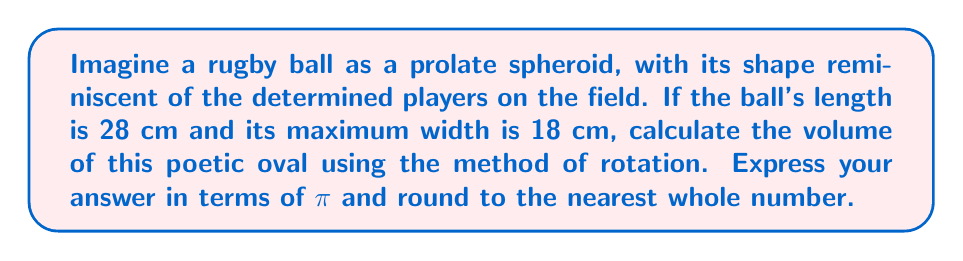Help me with this question. To solve this problem, we'll follow these steps:

1) A prolate spheroid is formed by rotating an ellipse around its major axis. The equation of the ellipse in the xy-plane is:

   $$ \frac{x^2}{a^2} + \frac{y^2}{b^2} = 1 $$

   where 2a is the length of the major axis and 2b is the length of the minor axis.

2) From the given dimensions:
   a = 14 cm (half of 28 cm)
   b = 9 cm (half of 18 cm)

3) Solve the equation for y:

   $$ y = \pm b\sqrt{1 - \frac{x^2}{a^2}} = \pm 9\sqrt{1 - \frac{x^2}{14^2}} $$

4) The volume of a solid of revolution is given by the integral:

   $$ V = \pi \int_{-a}^{a} [f(x)]^2 dx $$

5) Substituting our function:

   $$ V = \pi \int_{-14}^{14} \left(9\sqrt{1 - \frac{x^2}{14^2}}\right)^2 dx $$

6) Simplify:

   $$ V = 81\pi \int_{-14}^{14} \left(1 - \frac{x^2}{196}\right) dx $$

7) Integrate:

   $$ V = 81\pi \left[x - \frac{x^3}{3 \cdot 196}\right]_{-14}^{14} $$

8) Evaluate the integral:

   $$ V = 81\pi \left[(14 - \frac{14^3}{3 \cdot 196}) - (-14 - \frac{(-14)^3}{3 \cdot 196})\right] $$
   $$ V = 81\pi \left[28 - \frac{2744}{588}\right] $$
   $$ V = 81\π [28 - \frac{343}{73.5}] $$
   $$ V = 81\π [28 - 4.67] $$
   $$ V = 81\π \cdot 23.33 $$
   $$ V = 1889.73\π $$

9) Rounding to the nearest whole number:

   $$ V \approx 1890\pi \text{ cm}^3 $$
Answer: $1890\pi \text{ cm}^3$ 